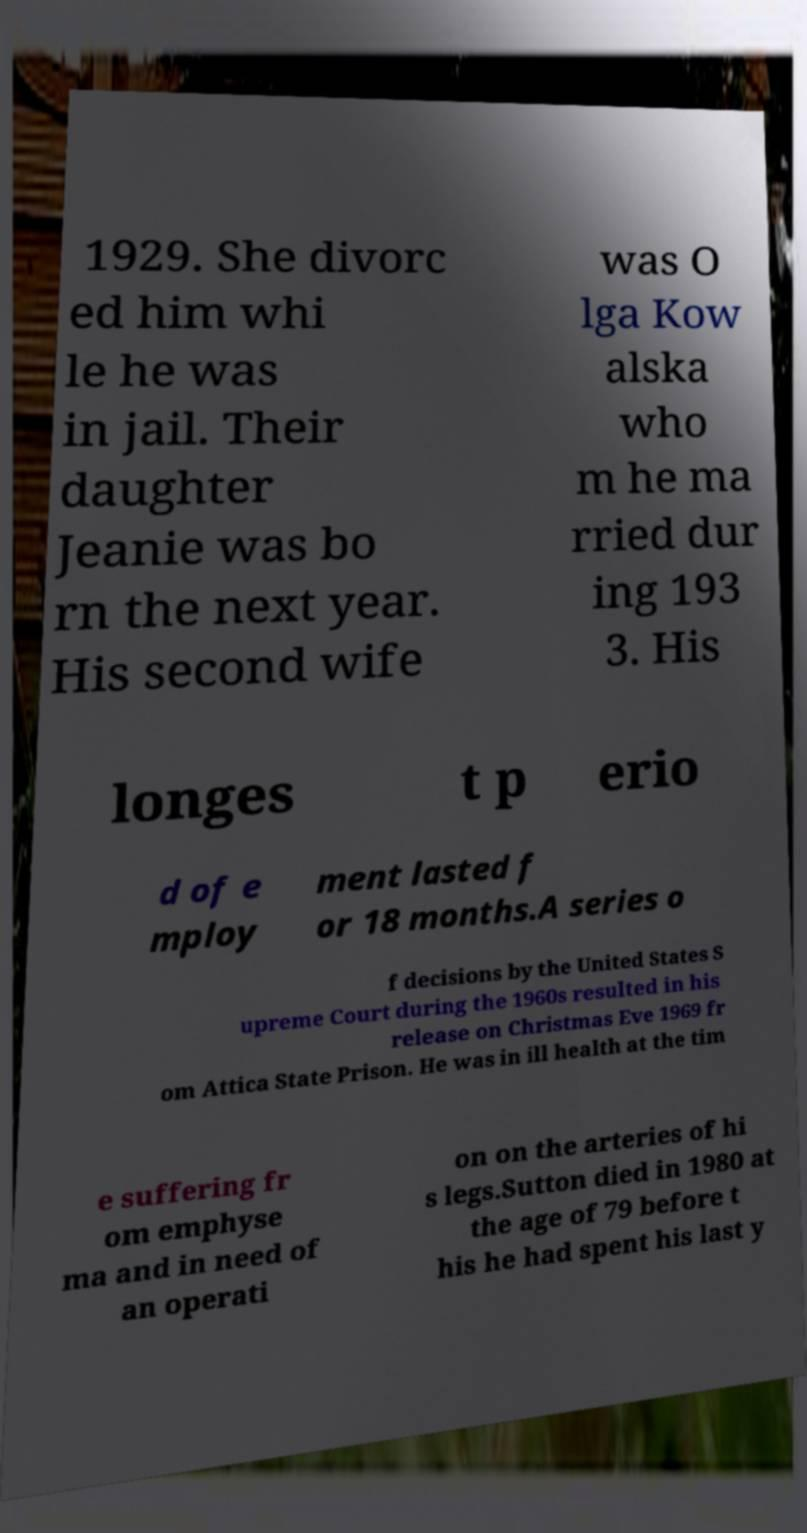Can you accurately transcribe the text from the provided image for me? 1929. She divorc ed him whi le he was in jail. Their daughter Jeanie was bo rn the next year. His second wife was O lga Kow alska who m he ma rried dur ing 193 3. His longes t p erio d of e mploy ment lasted f or 18 months.A series o f decisions by the United States S upreme Court during the 1960s resulted in his release on Christmas Eve 1969 fr om Attica State Prison. He was in ill health at the tim e suffering fr om emphyse ma and in need of an operati on on the arteries of hi s legs.Sutton died in 1980 at the age of 79 before t his he had spent his last y 